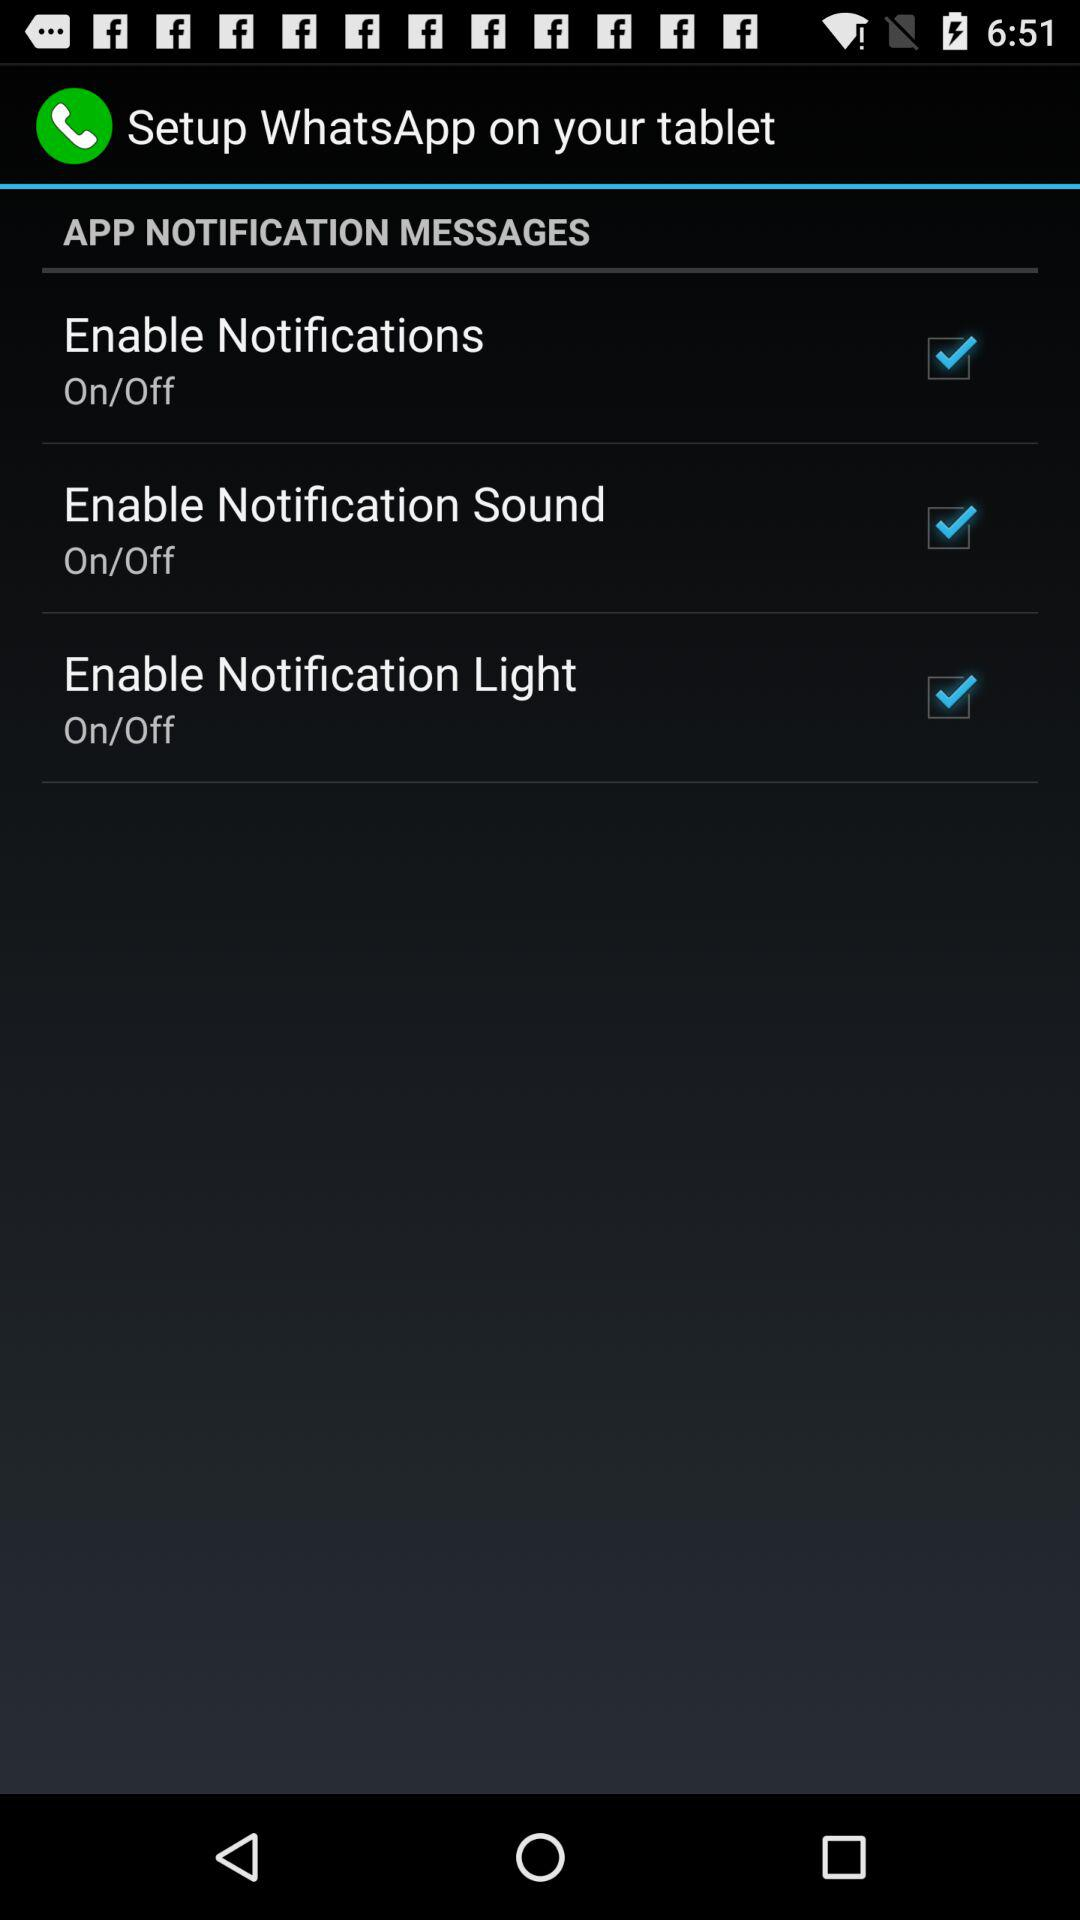What is the application name? The name of the application is "WhatsApp". 